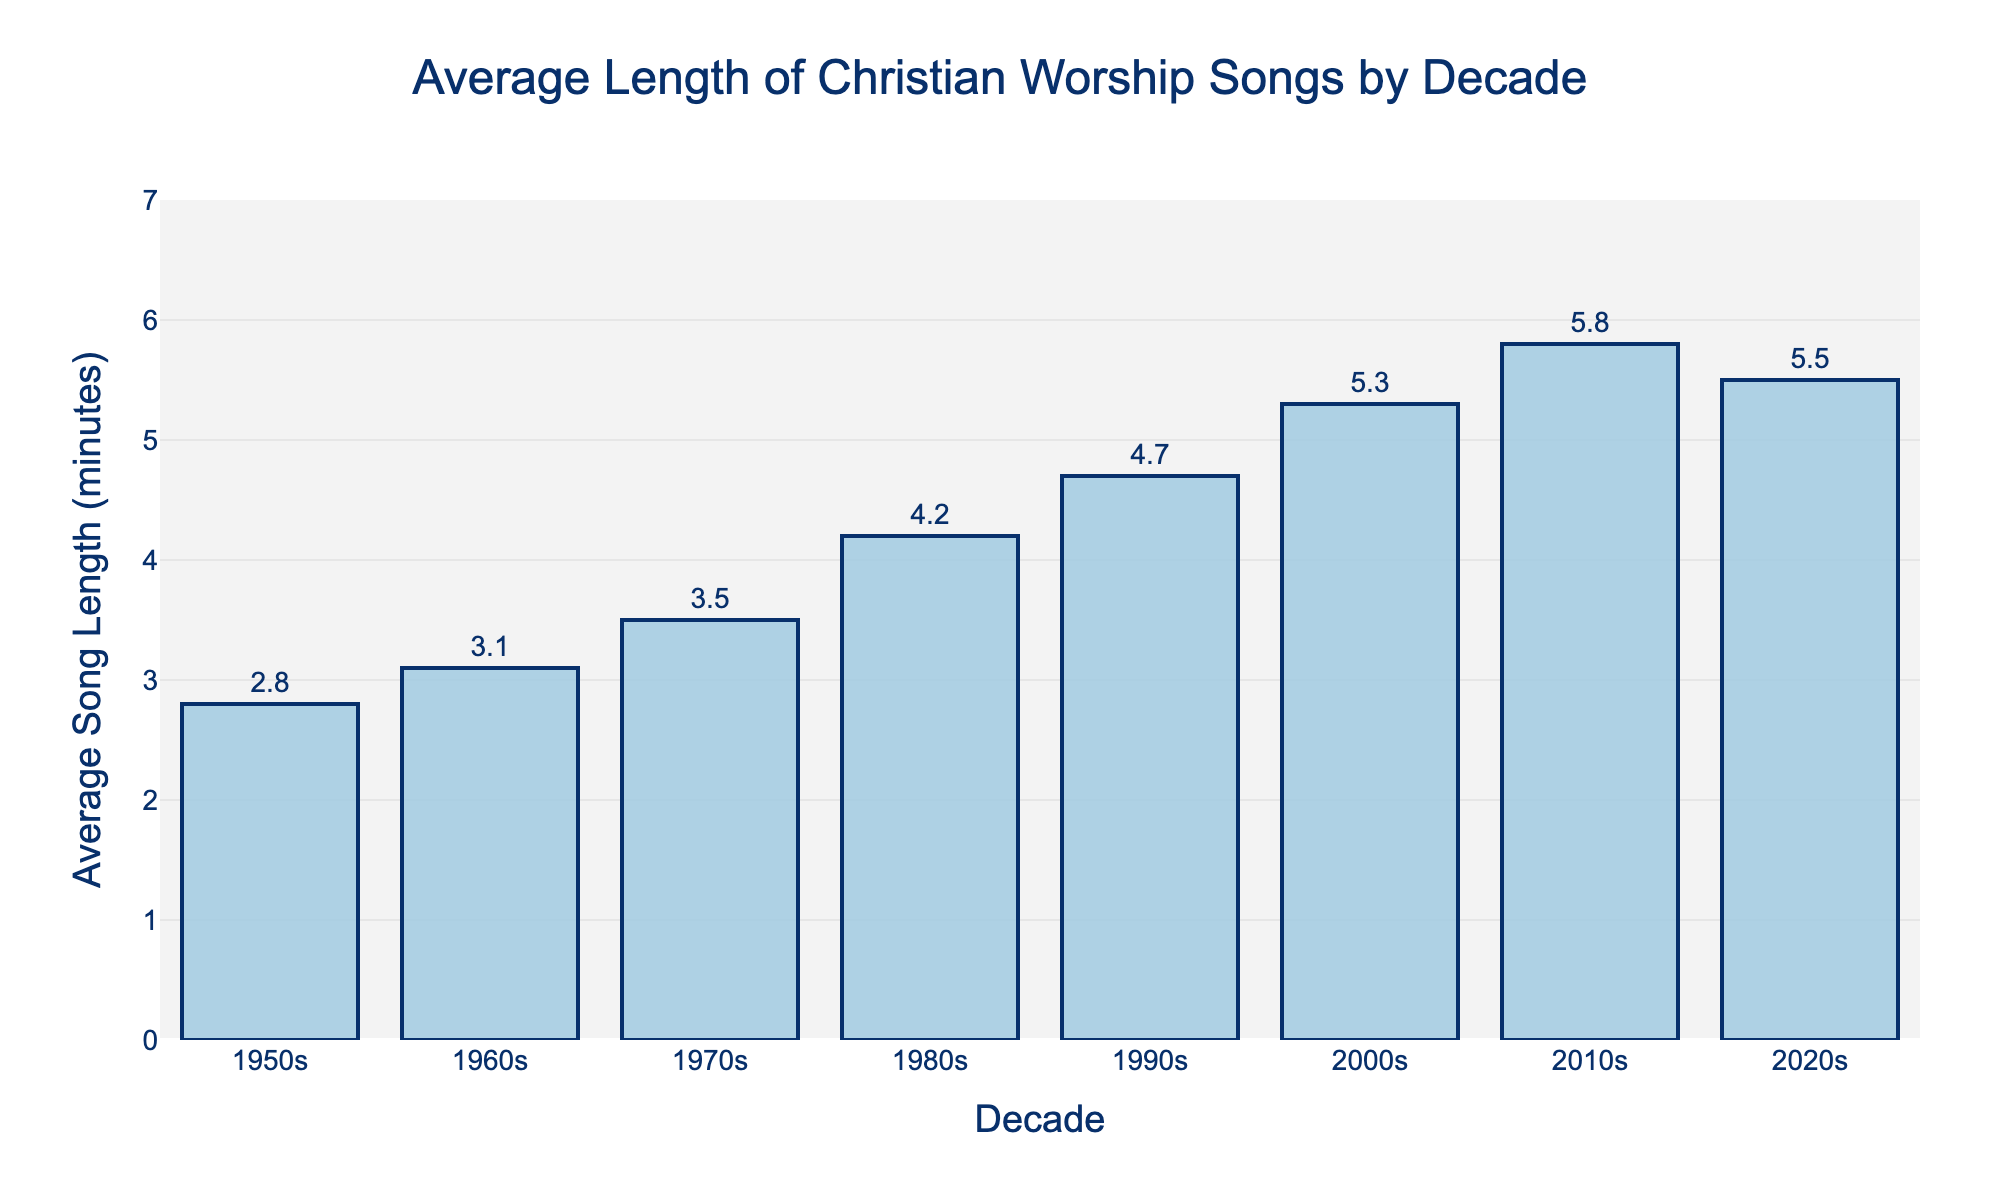What's the average length of songs in the 1970s? The chart shows a bar labeled "1970s," and the height corresponds to an average song length of 3.5 minutes.
Answer: 3.5 minutes During which decade did the average song length exceed 5 minutes for the first time? The chart shows the average song lengths by decade, and the first decade where the average song length exceeds 5 minutes is the 2000s.
Answer: 2000s Compare the average song lengths in the 1980s and 2020s. Which decade had longer songs on average? The chart shows that the average song length in the 1980s was 4.2 minutes, and in the 2020s it was 5.5 minutes. Since 5.5 minutes is greater than 4.2 minutes, the 2020s had longer songs on average.
Answer: 2020s By how many minutes did the average song length increase from the 1960s to the 2010s? From the chart, the average song length in the 1960s was 3.1 minutes, and in the 2010s it was 5.8 minutes. The increase can be calculated as 5.8 - 3.1 = 2.7 minutes.
Answer: 2.7 minutes What is the difference in average song length between the 1950s and 1990s? The average song length in the 1950s was 2.8 minutes and in the 1990s was 4.7 minutes. The difference is calculated as 4.7 - 2.8 = 1.9 minutes.
Answer: 1.9 minutes Identify the decade that witnessed the largest increase in average song length compared to its preceding decade. The largest increase can be identified by examining the differences between successive decades:
1960s-1950s: 3.1 - 2.8 = 0.3 minutes,
1970s-1960s: 3.5 - 3.1 = 0.4 minutes,
1980s-1970s: 4.2 - 3.5 = 0.7 minutes,
1990s-1980s: 4.7 - 4.2 = 0.5 minutes,
2000s-1990s: 5.3 - 4.7 = 0.6 minutes,
2010s-2000s: 5.8 - 5.3 = 0.5 minutes,
2020s-2010s: 5.5 - 5.8 = -0.3 minutes.
The 1980s show the largest increase of 0.7 minutes.
Answer: 1980s Which decade had the shortest average song length, and what was it? The chart indicates that the 1950s had the shortest average song length, at 2.8 minutes.
Answer: 1950s, 2.8 minutes How does the average song length in the 2000s compare to that in the 2010s, and by how much did it change? The average song length in the 2000s was 5.3 minutes, and in the 2010s it was 5.8 minutes. The difference can be calculated as 5.8 - 5.3 = 0.5 minutes.
Answer: The 2010s had 0.5 minutes longer songs Is there any decade where the average song length did not change or decreased compared to the previous decade? The average song length decreased in the 2020s compared to the 2010s. It went from 5.8 minutes in the 2010s to 5.5 minutes in the 2020s.
Answer: 2020s Calculate the total increase in average song length from the 1950s to the 2010s. The average song length in the 1950s was 2.8 minutes, and in the 2010s it was 5.8 minutes. The total increase can be calculated as 5.8 - 2.8 = 3.0 minutes.
Answer: 3.0 minutes 